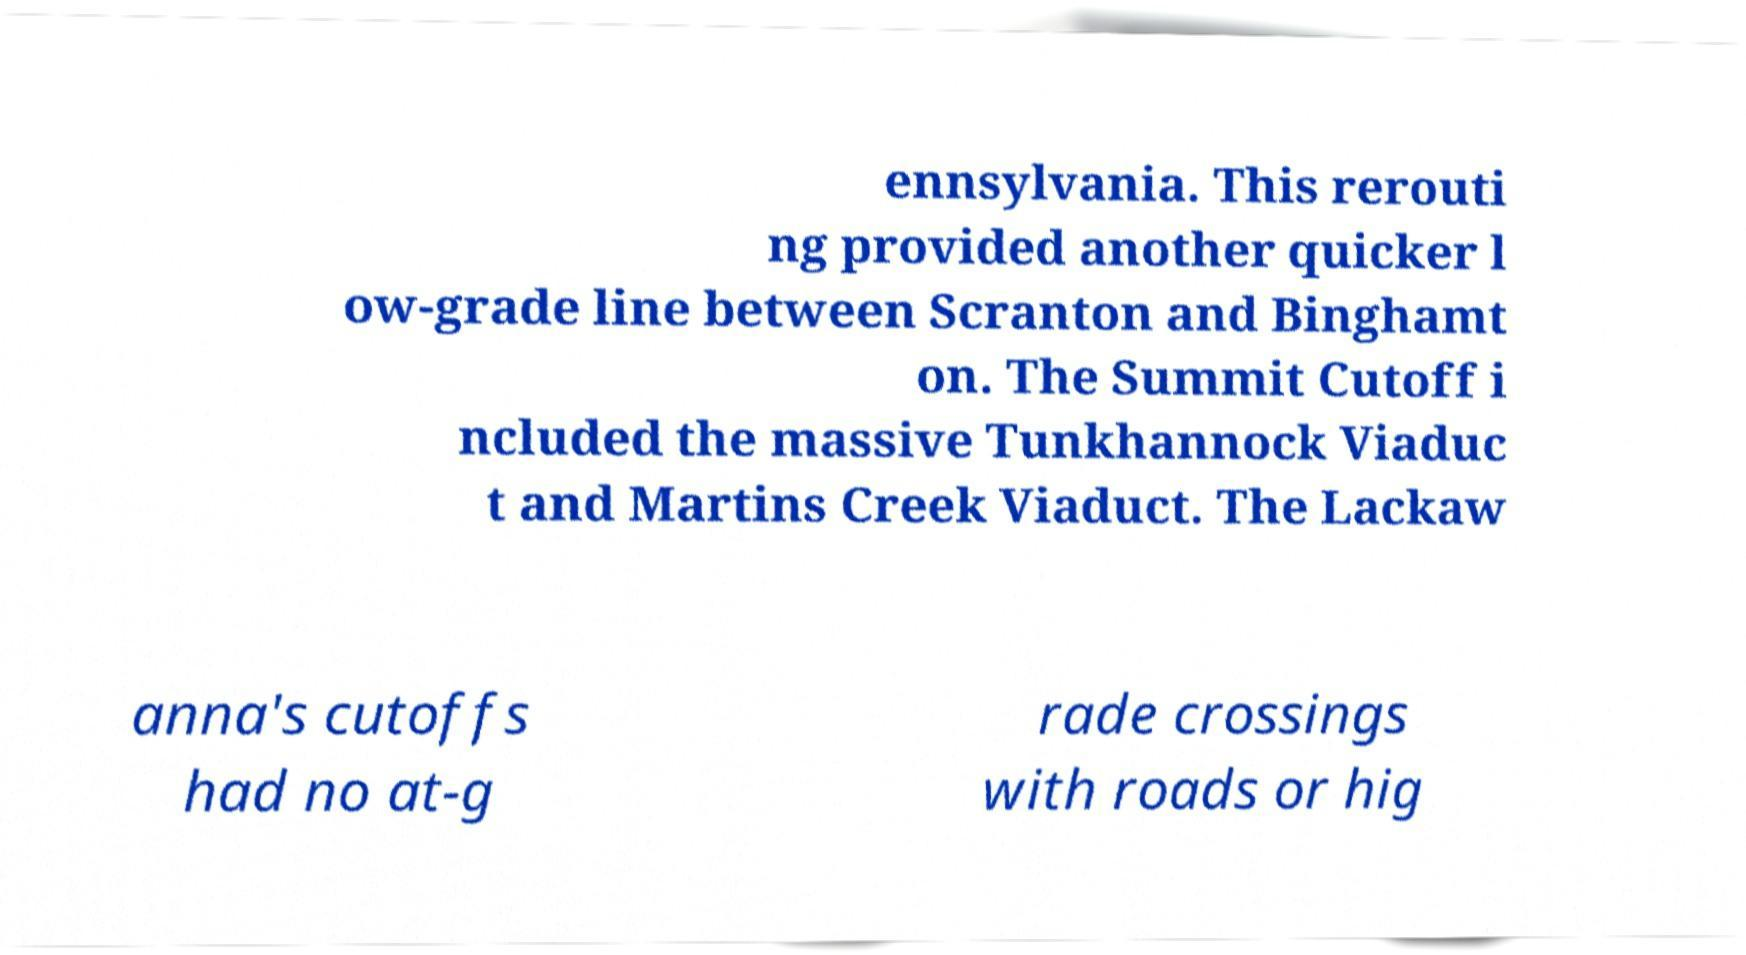Please read and relay the text visible in this image. What does it say? ennsylvania. This rerouti ng provided another quicker l ow-grade line between Scranton and Binghamt on. The Summit Cutoff i ncluded the massive Tunkhannock Viaduc t and Martins Creek Viaduct. The Lackaw anna's cutoffs had no at-g rade crossings with roads or hig 